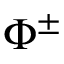<formula> <loc_0><loc_0><loc_500><loc_500>\Phi ^ { \pm }</formula> 